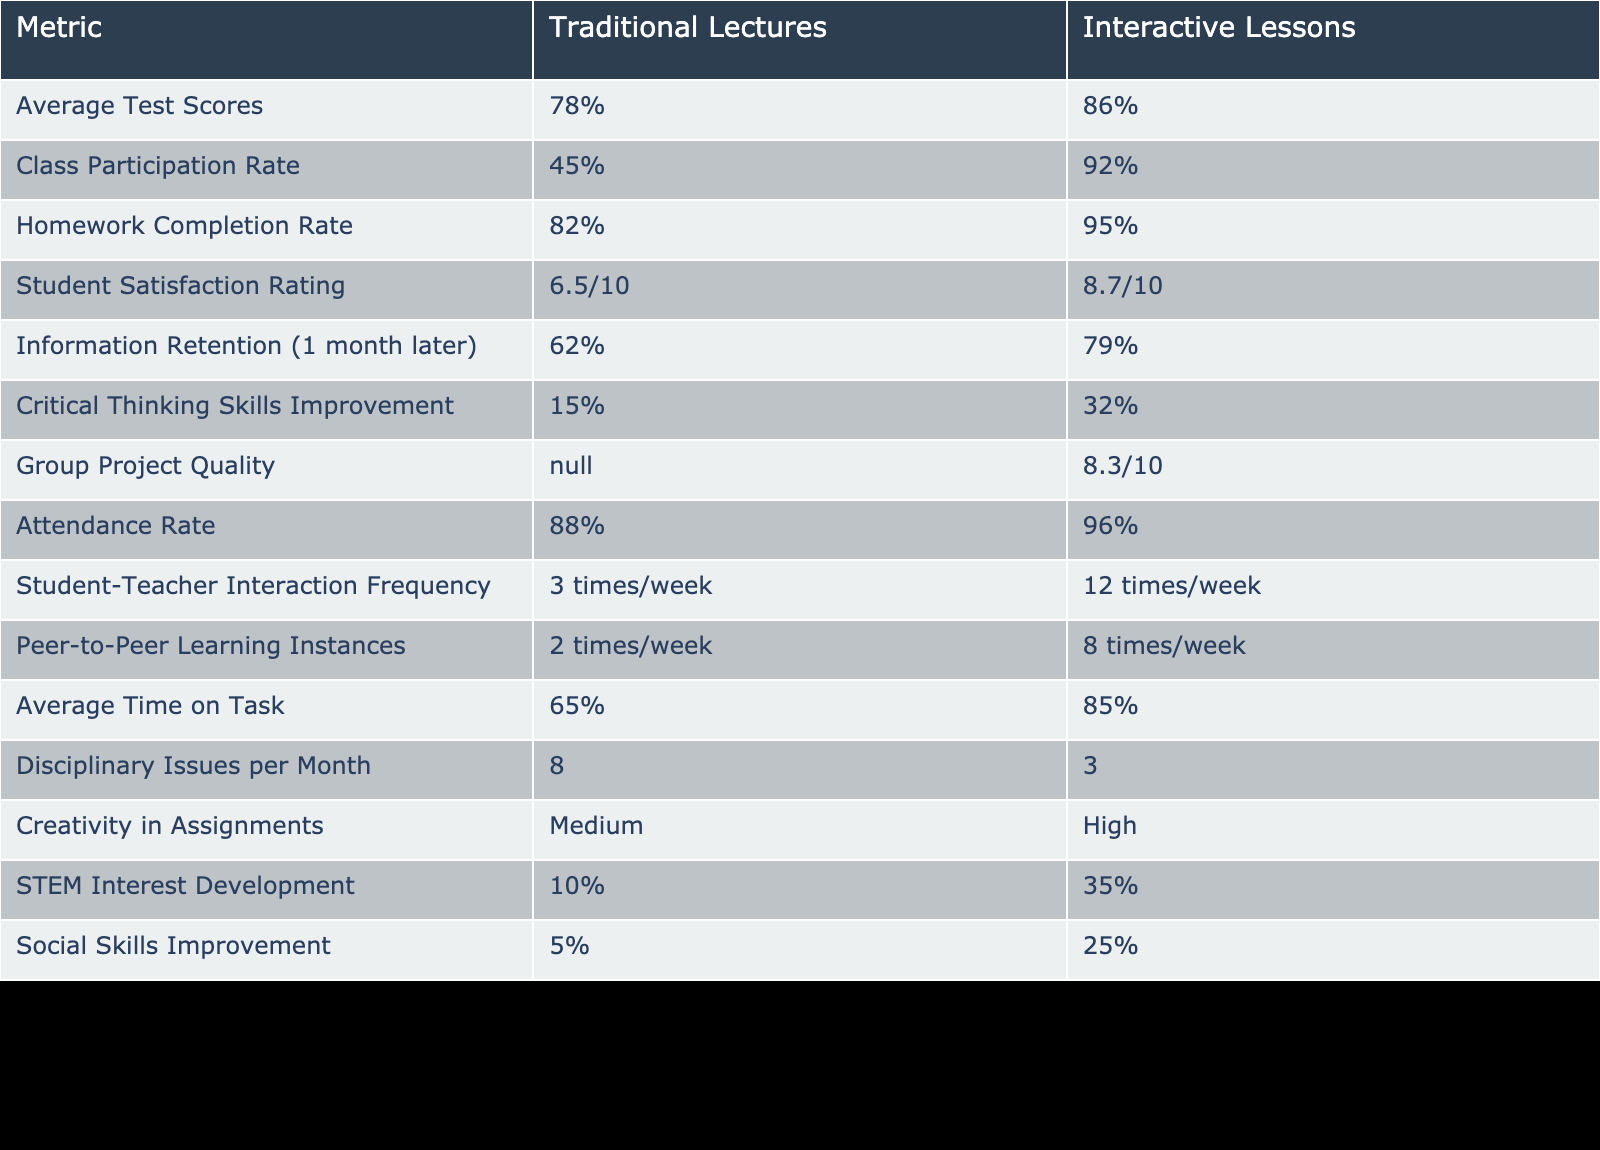What is the average test score for interactive lessons? The table shows that the average test score for interactive lessons is 86%.
Answer: 86% What is the class participation rate in traditional lectures? According to the table, the class participation rate in traditional lectures is 45%.
Answer: 45% How much higher is the homework completion rate in interactive lessons compared to traditional lectures? The homework completion rate in interactive lessons is 95%, while in traditional lectures it is 82%. The difference is 95% - 82% = 13%.
Answer: 13% Is the student satisfaction rating for interactive lessons greater than 8 out of 10? The student satisfaction rating for interactive lessons is 8.7/10, which is greater than 8. Therefore, the statement is true.
Answer: Yes How many more times per week do students interact with teachers in interactive lessons compared to traditional lectures? The table indicates that in traditional lectures, student-teacher interaction is 3 times/week, and in interactive lessons, it is 12 times/week. The difference is 12 - 3 = 9 times.
Answer: 9 times What is the information retention rate one month later for traditional lectures and interactive lessons? The information retention rate for traditional lectures is 62%, while for interactive lessons it is 79%.
Answer: Traditional: 62%, Interactive: 79% Does the attendance rate increase when comparing interactive lessons to traditional lectures? The attendance rate for traditional lectures is 88% and for interactive lessons is 96%, indicating an increase in attendance. Therefore, the statement is true.
Answer: Yes What is the percentage increase of STEM interest development from traditional lectures to interactive lessons? Traditional lectures have a STEM interest development of 10% and interactive lessons have 35%. The increase is calculated as (35% - 10%) / 10% * 100% = 250%.
Answer: 250% What is the average number of disciplinary issues per month in traditional lectures compared to interactive lessons? The average number of disciplinary issues per month in traditional lectures is 8, while in interactive lessons it is 3.
Answer: Traditional: 8, Interactive: 3 